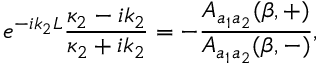<formula> <loc_0><loc_0><loc_500><loc_500>e ^ { - i k _ { 2 } L } \frac { \kappa _ { 2 } - i k _ { 2 } } { \kappa _ { 2 } + i k _ { 2 } } = - \frac { A _ { a _ { 1 } a _ { 2 } } ( \beta , + ) } { A _ { a _ { 1 } a _ { 2 } } ( \beta , - ) } ,</formula> 